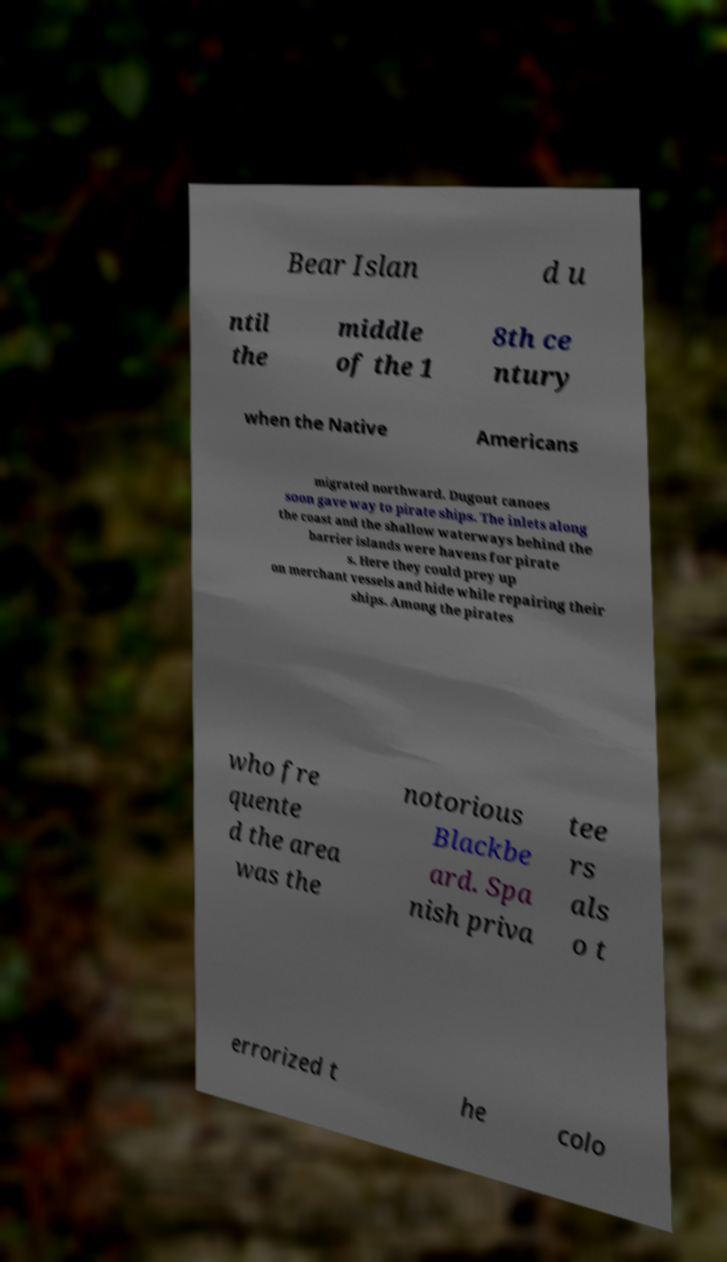Can you read and provide the text displayed in the image?This photo seems to have some interesting text. Can you extract and type it out for me? Bear Islan d u ntil the middle of the 1 8th ce ntury when the Native Americans migrated northward. Dugout canoes soon gave way to pirate ships. The inlets along the coast and the shallow waterways behind the barrier islands were havens for pirate s. Here they could prey up on merchant vessels and hide while repairing their ships. Among the pirates who fre quente d the area was the notorious Blackbe ard. Spa nish priva tee rs als o t errorized t he colo 